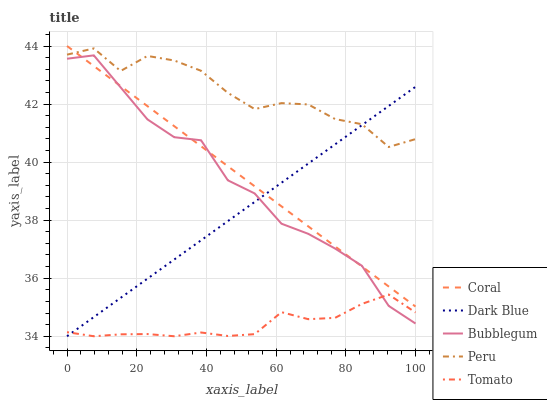Does Tomato have the minimum area under the curve?
Answer yes or no. Yes. Does Peru have the maximum area under the curve?
Answer yes or no. Yes. Does Dark Blue have the minimum area under the curve?
Answer yes or no. No. Does Dark Blue have the maximum area under the curve?
Answer yes or no. No. Is Coral the smoothest?
Answer yes or no. Yes. Is Bubblegum the roughest?
Answer yes or no. Yes. Is Dark Blue the smoothest?
Answer yes or no. No. Is Dark Blue the roughest?
Answer yes or no. No. Does Tomato have the lowest value?
Answer yes or no. Yes. Does Coral have the lowest value?
Answer yes or no. No. Does Coral have the highest value?
Answer yes or no. Yes. Does Dark Blue have the highest value?
Answer yes or no. No. Is Bubblegum less than Peru?
Answer yes or no. Yes. Is Peru greater than Bubblegum?
Answer yes or no. Yes. Does Bubblegum intersect Dark Blue?
Answer yes or no. Yes. Is Bubblegum less than Dark Blue?
Answer yes or no. No. Is Bubblegum greater than Dark Blue?
Answer yes or no. No. Does Bubblegum intersect Peru?
Answer yes or no. No. 